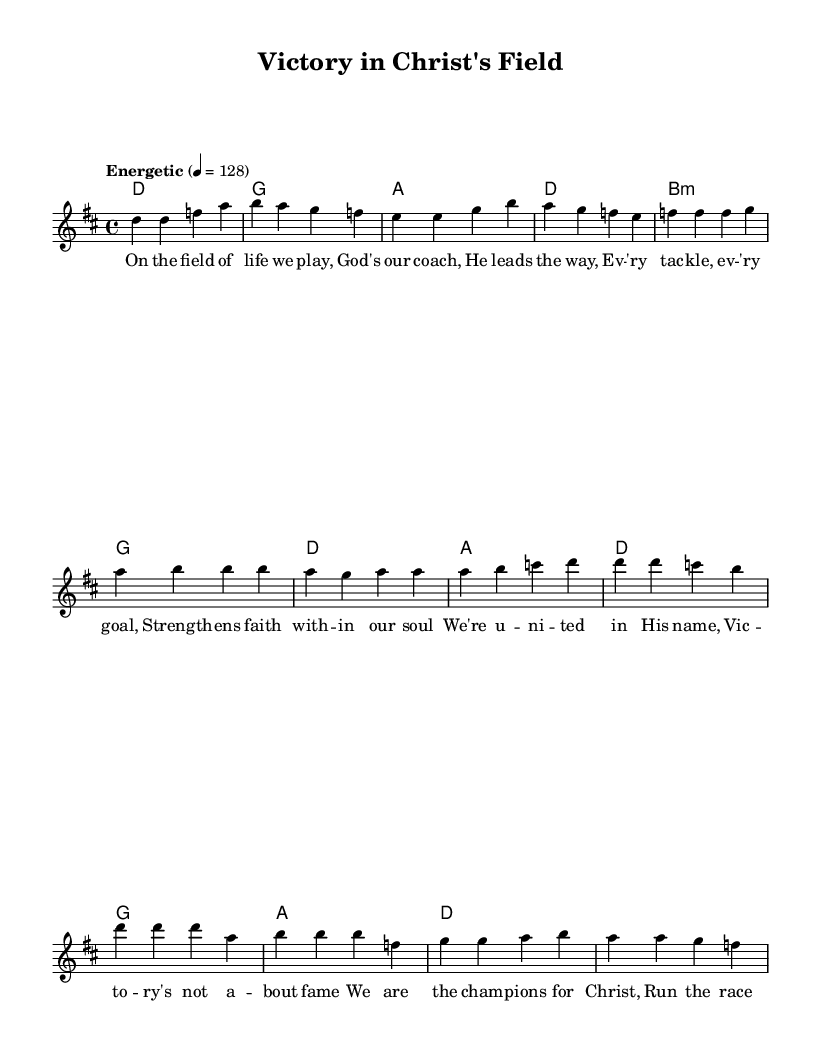What is the key signature of this music? The piece is in D major, which is indicated by the presence of two sharps (F# and C#) in the key signature.
Answer: D major What is the time signature of this music? The time signature shown at the beginning of the score is 4/4. This means there are four beats in each measure and a quarter note gets one beat.
Answer: 4/4 What is the tempo marking for this piece? The tempo marking is shown as "Energetic" with a metronome marking of 4 = 128, indicating a lively pace.
Answer: Energetic How many sections are in the structure of this music? The music consists of three main sections: Verse, Pre-Chorus, and Chorus. Each section has its own distinct lyrics and melody.
Answer: Three What is the primary theme expressed in the lyrics? The lyrics center around themes of faith, unity, and victory in Christ, emphasizing spiritual strength and community through sports metaphors.
Answer: Faith and victory Which chord is used in the pre-chorus? The first chord in the pre-chorus is B minor, as indicated in the chord progression.
Answer: B minor What is the overall message conveyed by the chorus? The chorus expresses a sense of triumph and pride in being part of God's team, celebrating victory through faith and community.
Answer: Champions for Christ 